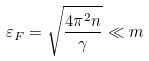Convert formula to latex. <formula><loc_0><loc_0><loc_500><loc_500>\varepsilon _ { F } = \sqrt { \frac { 4 \pi ^ { 2 } n } \gamma } \ll m</formula> 